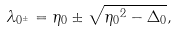<formula> <loc_0><loc_0><loc_500><loc_500>\lambda _ { 0 ^ { \pm } } = \eta _ { 0 } \pm \sqrt { { \eta _ { 0 } } ^ { 2 } - \Delta _ { 0 } } ,</formula> 